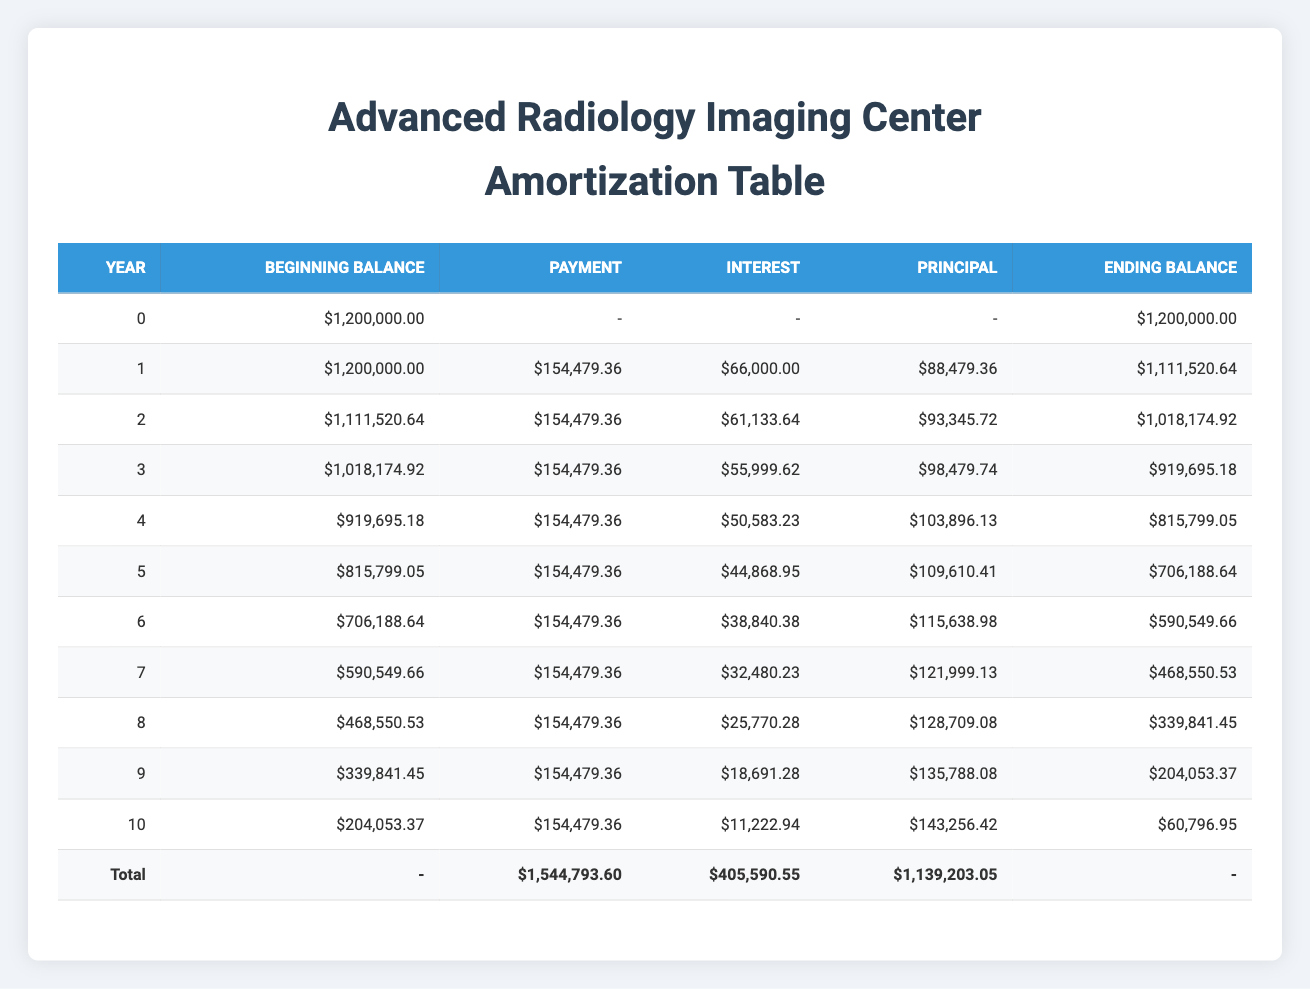What is the total loan amount for the Advanced Radiology Imaging Center? The total loan amount listed in the table is clearly stated as 1,200,000.00 in the row labeled "Beginning Balance" for year 0.
Answer: 1,200,000.00 What is the monthly payment amount for the loan? The monthly payment amount is explicitly shown as 154,479.36 under the "Payment" column for all years.
Answer: 154,479.36 In which year is the principal payment the highest? By examining the "Principal" amounts across all years, the highest principal payment is seen in year 10 at 143,256.42.
Answer: Year 10 What is the total amount paid in interest over the loan term? We can find the total interest by summing all values in the "Interest" column, yielding (66,000.00 + 61,133.64 + 55,999.62 + 50,583.23 + 44,868.95 + 38,840.38 + 32,480.23 + 25,770.28 + 18,691.28 + 11,222.94) = 405,590.55.
Answer: 405,590.55 True or False: The ending balance at year 5 is less than the ending balance at year 6. To evaluate this statement, we check the "Ending Balance" values. The ending balance for year 5 is 706,188.64, while for year 6 it is 590,549.66. Since 706,188.64 is greater than 590,549.66, the statement is false.
Answer: False What is the difference between the annual revenue for year 6 and operational costs for year 6? The annual revenue for year 6 is 1,000,000.00, and the operational costs for the same year are 400,000.00. The difference is calculated as 1,000,000.00 - 400,000.00 = 600,000.00.
Answer: 600,000.00 How much total principal is paid off by the end of year 4? To find this, we sum the values in the "Principal" column from years 1 to 4: (88,479.36 + 93,345.72 + 98,479.74 + 103,896.13) = 384,201.95.
Answer: 384,201.95 In which year does the loan balance drop below 500,000.00? We review the "Ending Balance" column, which shows that the loan balance first drops below 500,000.00 at the end of year 6 when it is 590,549.66, indicating it does not drop below 500,000.00 until after year 6.
Answer: Year 7 What is the total investment amount for the Advanced Radiology Imaging Center? The total investment includes equipment, construction, and IT infrastructure, which sums to 1,500,000.00 as shown at the start of the data.
Answer: 1,500,000.00 